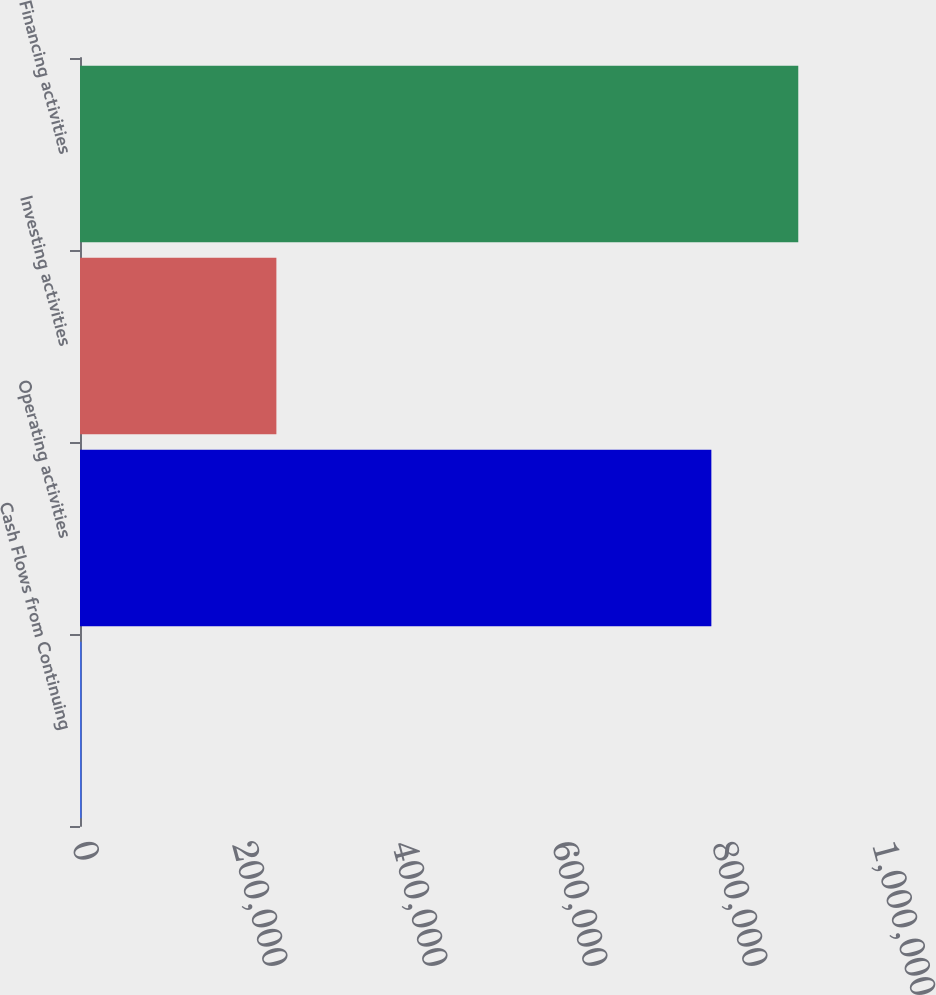Convert chart to OTSL. <chart><loc_0><loc_0><loc_500><loc_500><bar_chart><fcel>Cash Flows from Continuing<fcel>Operating activities<fcel>Investing activities<fcel>Financing activities<nl><fcel>2018<fcel>789193<fcel>245480<fcel>897838<nl></chart> 